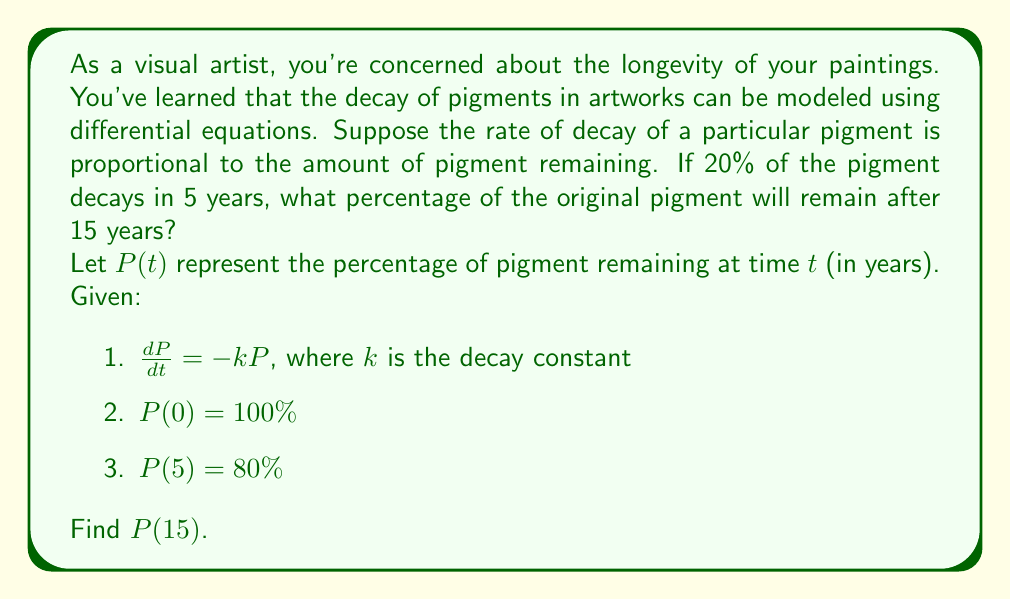Provide a solution to this math problem. Let's solve this step-by-step:

1) The differential equation $\frac{dP}{dt} = -kP$ is a separable equation. We can solve it as follows:

   $$\frac{dP}{P} = -k dt$$
   $$\int \frac{dP}{P} = -k \int dt$$
   $$\ln|P| = -kt + C$$
   $$P = e^{-kt + C} = Ae^{-kt}$$, where $A = e^C$

2) Using the initial condition $P(0) = 100\%$:
   
   $100 = Ae^{-k(0)} = A$

3) So our general solution is:

   $$P(t) = 100e^{-kt}$$

4) Now we can use the condition $P(5) = 80\%$ to find $k$:

   $$80 = 100e^{-k(5)}$$
   $$0.8 = e^{-5k}$$
   $$\ln(0.8) = -5k$$
   $$k = -\frac{\ln(0.8)}{5} \approx 0.0446$$

5) Now that we know $k$, we can find $P(15)$:

   $$P(15) = 100e^{-0.0446(15)}$$
   $$P(15) = 100e^{-0.669} \approx 51.2\%$$

Therefore, after 15 years, approximately 51.2% of the original pigment will remain.
Answer: 51.2% of the original pigment will remain after 15 years. 